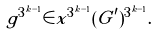<formula> <loc_0><loc_0><loc_500><loc_500>g ^ { 3 ^ { k - 1 } } \in x ^ { 3 ^ { k - 1 } } ( G ^ { \prime } ) ^ { 3 ^ { k - 1 } } .</formula> 